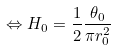<formula> <loc_0><loc_0><loc_500><loc_500>\Leftrightarrow H _ { 0 } = \frac { 1 } { 2 } \frac { \theta _ { 0 } } { \pi r _ { 0 } ^ { 2 } }</formula> 